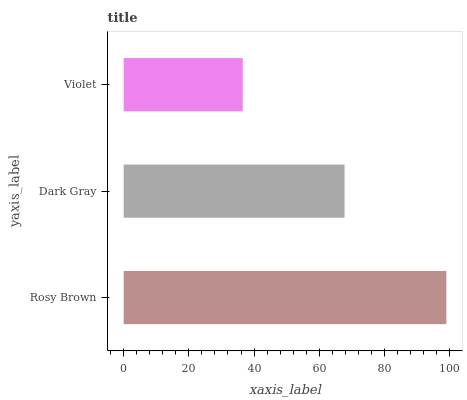Is Violet the minimum?
Answer yes or no. Yes. Is Rosy Brown the maximum?
Answer yes or no. Yes. Is Dark Gray the minimum?
Answer yes or no. No. Is Dark Gray the maximum?
Answer yes or no. No. Is Rosy Brown greater than Dark Gray?
Answer yes or no. Yes. Is Dark Gray less than Rosy Brown?
Answer yes or no. Yes. Is Dark Gray greater than Rosy Brown?
Answer yes or no. No. Is Rosy Brown less than Dark Gray?
Answer yes or no. No. Is Dark Gray the high median?
Answer yes or no. Yes. Is Dark Gray the low median?
Answer yes or no. Yes. Is Violet the high median?
Answer yes or no. No. Is Rosy Brown the low median?
Answer yes or no. No. 